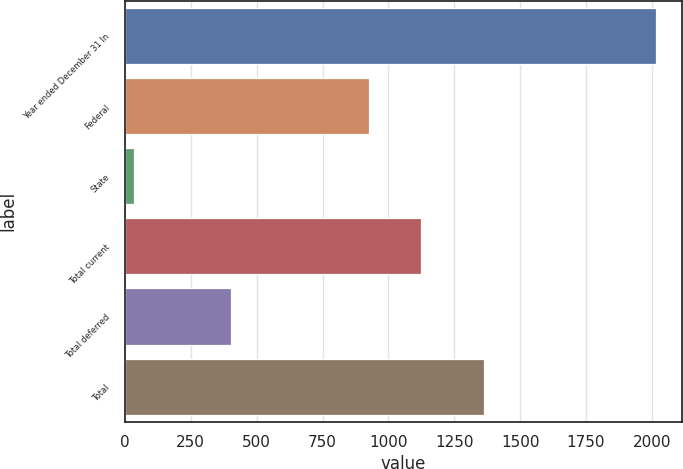<chart> <loc_0><loc_0><loc_500><loc_500><bar_chart><fcel>Year ended December 31 In<fcel>Federal<fcel>State<fcel>Total current<fcel>Total deferred<fcel>Total<nl><fcel>2015<fcel>927<fcel>33<fcel>1125.2<fcel>404<fcel>1364<nl></chart> 